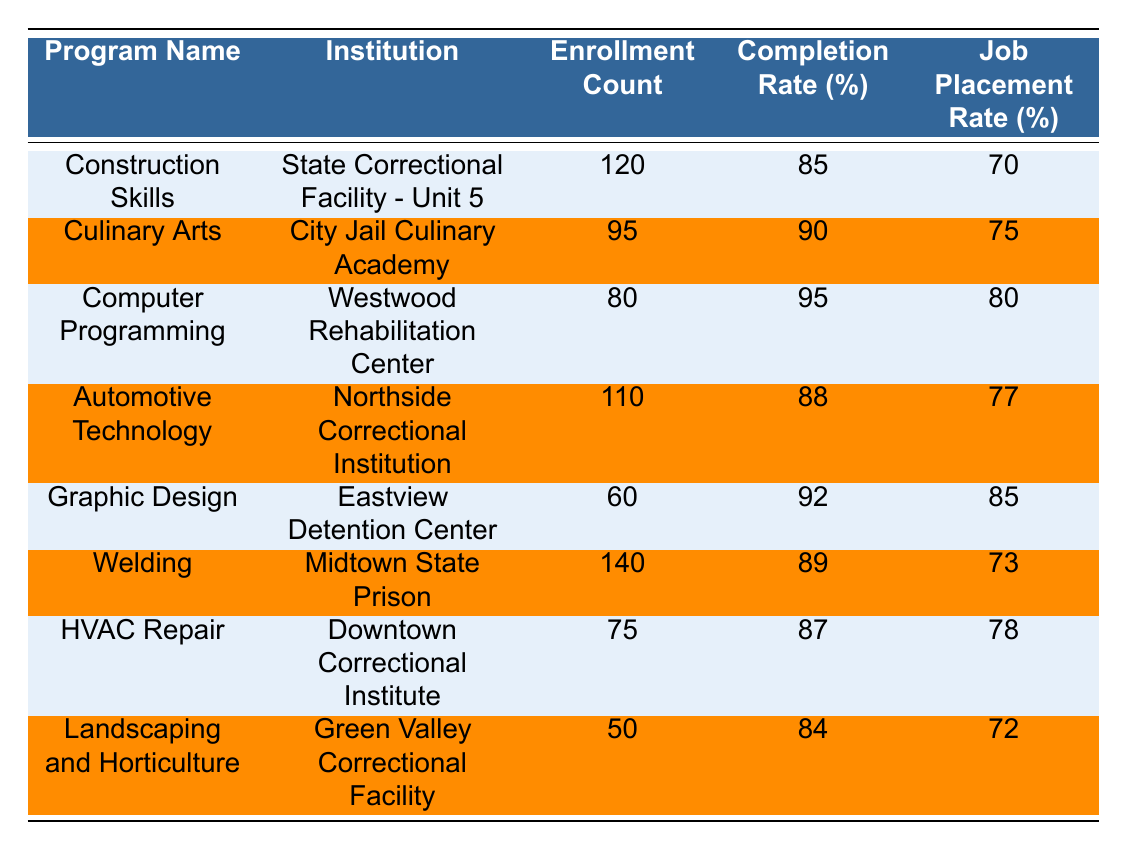What vocational training program has the highest enrollment count? The table shows the enrollment counts for each program. By comparing the numbers, "Welding" has the highest enrollment count at 140.
Answer: Welding What is the completion rate for the Culinary Arts program? The table indicates that the completion rate for the Culinary Arts program is 90%.
Answer: 90% Which program has the lowest completion rate? By checking the completion rates listed in the table, "Landscaping and Horticulture" has the lowest completion rate at 84%.
Answer: Landscaping and Horticulture What are the job placement rates for programs with an enrollment count of over 100? The programs with over 100 enrollments are "Construction Skills" (70%), "Automotive Technology" (77%), and "Welding" (73%). Their job placement rates are 70%, 77%, and 73%, respectively.
Answer: 70%, 77%, 73% Is the job placement rate for the Computer Programming program higher than that for the HVAC Repair program? The job placement rate for Computer Programming is 80%, while for HVAC Repair, it is 78%. Since 80% is greater than 78%, the statement is true.
Answer: Yes Calculate the average enrollment count across all programs. Adding all the enrollment counts: 120 + 95 + 80 + 110 + 60 + 140 + 75 + 50 = 830. There are 8 programs, so the average is 830 / 8 = 103.75.
Answer: 103.75 Which institution has the highest job placement rate? From the table, "Graphic Design" has the highest job placement rate at 85%.
Answer: Graphic Design How many programs have a job placement rate of 75% or higher? The programs with job placement rates at or above 75% are "Culinary Arts" (75%), "Computer Programming" (80%), "Automotive Technology" (77%), "Graphic Design" (85%), and "HVAC Repair" (78%). This means 5 programs qualify.
Answer: 5 What is the difference between the highest and lowest enrollment counts? The highest enrollment count is for "Welding" at 140, and the lowest is "Landscaping and Horticulture" at 50. The difference is 140 - 50 = 90.
Answer: 90 Which vocational program has a better job placement rate: Construction Skills or HVAC Repair? Construction Skills has a job placement rate of 70%, while HVAC Repair has 78%. Since 78% is higher than 70%, HVAC Repair has a better job placement rate.
Answer: HVAC Repair 